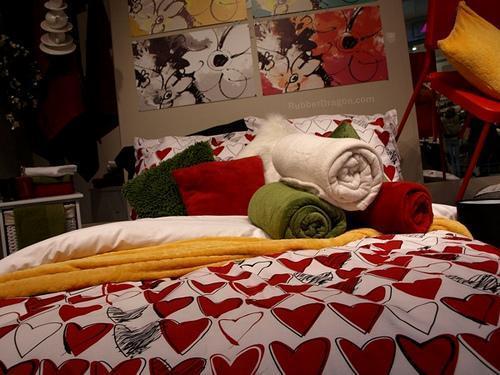How many beds are in the picture?
Give a very brief answer. 1. How many rolled blankets are in the picture?
Give a very brief answer. 3. 